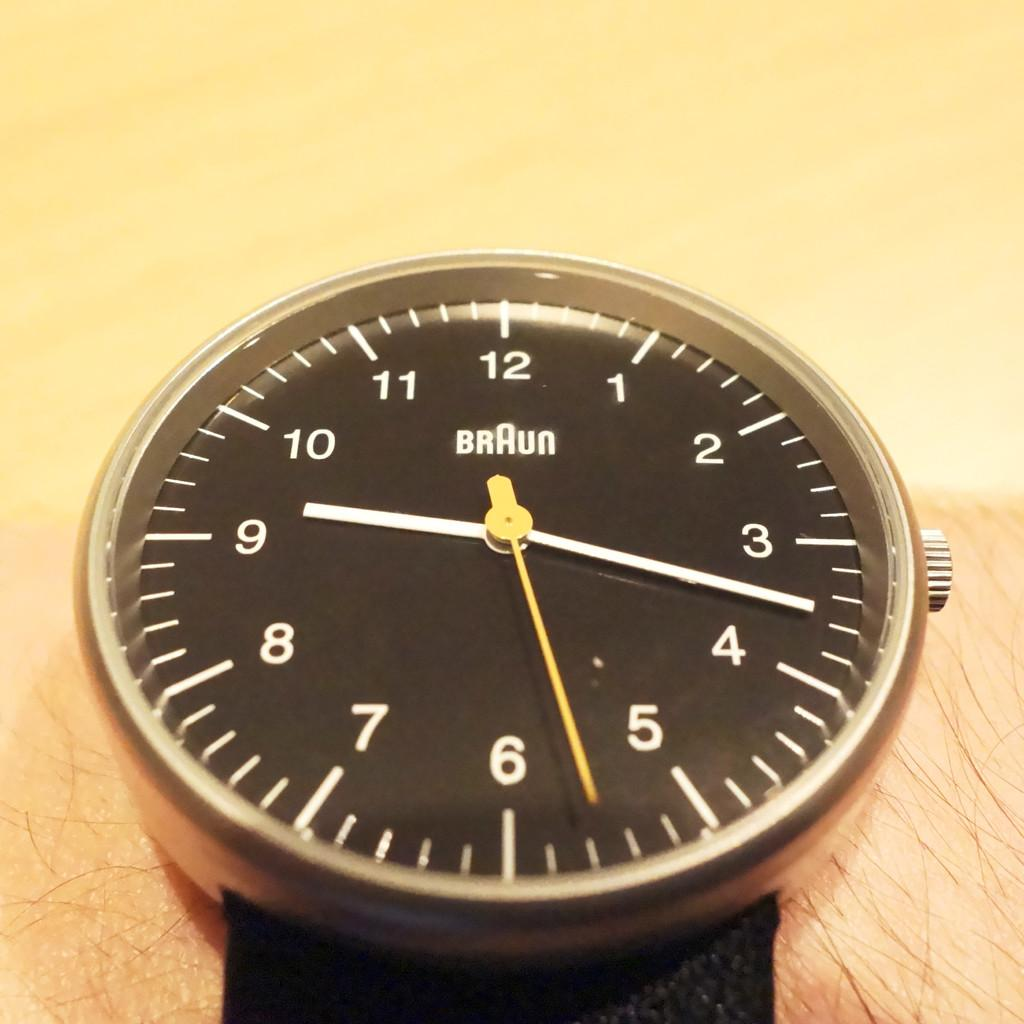<image>
Relay a brief, clear account of the picture shown. Watch with a black band with BRAUN printed on the faceplate. 